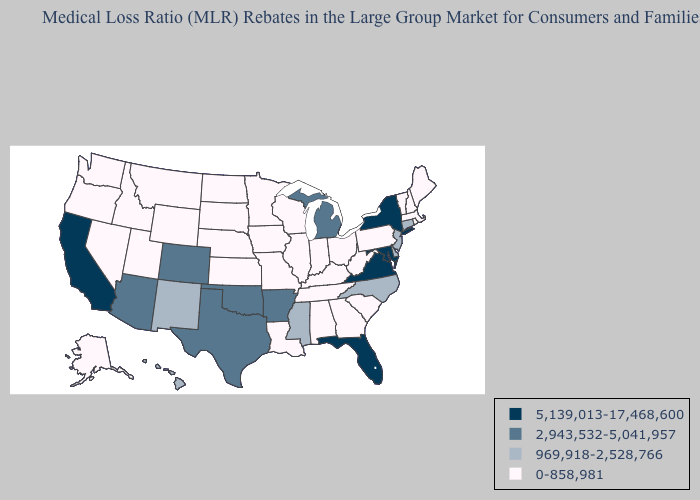What is the value of Kentucky?
Write a very short answer. 0-858,981. Among the states that border Rhode Island , which have the lowest value?
Give a very brief answer. Massachusetts. Which states hav the highest value in the South?
Short answer required. Florida, Maryland, Virginia. Name the states that have a value in the range 2,943,532-5,041,957?
Give a very brief answer. Arizona, Arkansas, Colorado, Michigan, Oklahoma, Texas. Name the states that have a value in the range 5,139,013-17,468,600?
Short answer required. California, Florida, Maryland, New York, Virginia. Name the states that have a value in the range 2,943,532-5,041,957?
Be succinct. Arizona, Arkansas, Colorado, Michigan, Oklahoma, Texas. Does Nebraska have the lowest value in the USA?
Keep it brief. Yes. Which states have the lowest value in the South?
Short answer required. Alabama, Georgia, Kentucky, Louisiana, South Carolina, Tennessee, West Virginia. Does Massachusetts have the lowest value in the Northeast?
Give a very brief answer. Yes. Which states have the lowest value in the South?
Short answer required. Alabama, Georgia, Kentucky, Louisiana, South Carolina, Tennessee, West Virginia. Does California have the highest value in the West?
Short answer required. Yes. Among the states that border Idaho , which have the highest value?
Concise answer only. Montana, Nevada, Oregon, Utah, Washington, Wyoming. Does Maryland have the highest value in the USA?
Write a very short answer. Yes. Which states hav the highest value in the MidWest?
Answer briefly. Michigan. 